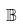<formula> <loc_0><loc_0><loc_500><loc_500>\mathbb { B }</formula> 